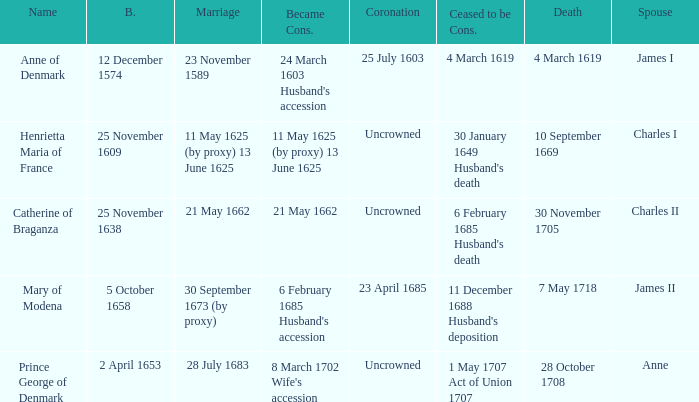On what date did James II take a consort? 6 February 1685 Husband's accession. 